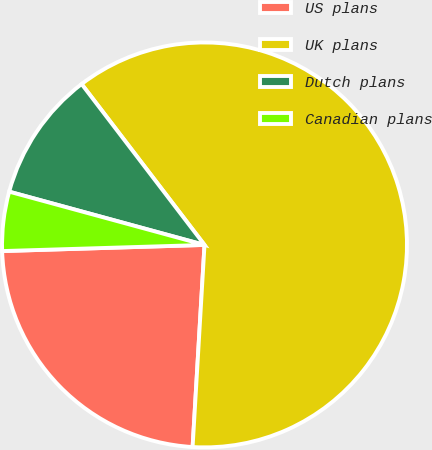<chart> <loc_0><loc_0><loc_500><loc_500><pie_chart><fcel>US plans<fcel>UK plans<fcel>Dutch plans<fcel>Canadian plans<nl><fcel>23.58%<fcel>61.32%<fcel>10.38%<fcel>4.72%<nl></chart> 